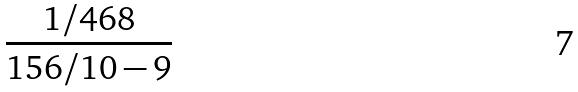<formula> <loc_0><loc_0><loc_500><loc_500>\frac { 1 / 4 6 8 } { 1 5 6 / 1 0 - 9 }</formula> 